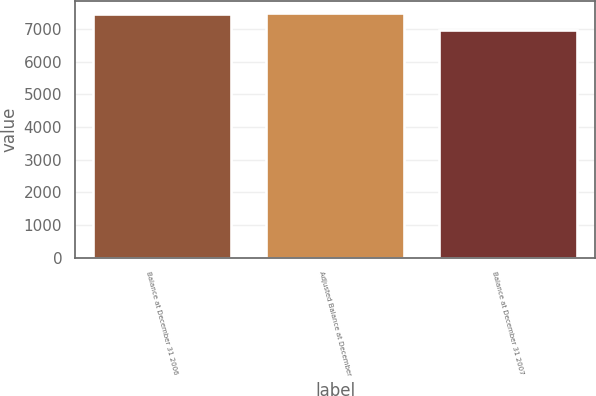Convert chart to OTSL. <chart><loc_0><loc_0><loc_500><loc_500><bar_chart><fcel>Balance at December 31 2006<fcel>Adjusted Balance at December<fcel>Balance at December 31 2007<nl><fcel>7445<fcel>7494.9<fcel>6966<nl></chart> 